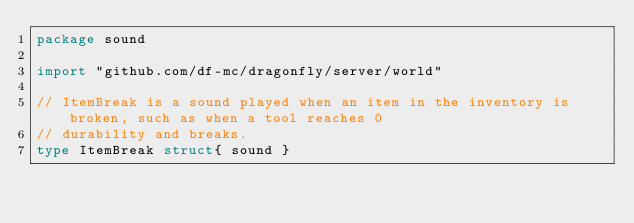Convert code to text. <code><loc_0><loc_0><loc_500><loc_500><_Go_>package sound

import "github.com/df-mc/dragonfly/server/world"

// ItemBreak is a sound played when an item in the inventory is broken, such as when a tool reaches 0
// durability and breaks.
type ItemBreak struct{ sound }
</code> 